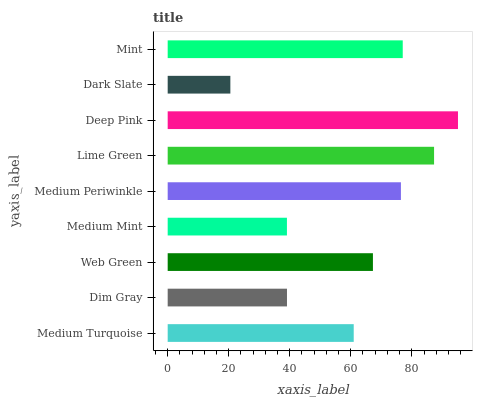Is Dark Slate the minimum?
Answer yes or no. Yes. Is Deep Pink the maximum?
Answer yes or no. Yes. Is Dim Gray the minimum?
Answer yes or no. No. Is Dim Gray the maximum?
Answer yes or no. No. Is Medium Turquoise greater than Dim Gray?
Answer yes or no. Yes. Is Dim Gray less than Medium Turquoise?
Answer yes or no. Yes. Is Dim Gray greater than Medium Turquoise?
Answer yes or no. No. Is Medium Turquoise less than Dim Gray?
Answer yes or no. No. Is Web Green the high median?
Answer yes or no. Yes. Is Web Green the low median?
Answer yes or no. Yes. Is Dim Gray the high median?
Answer yes or no. No. Is Dim Gray the low median?
Answer yes or no. No. 